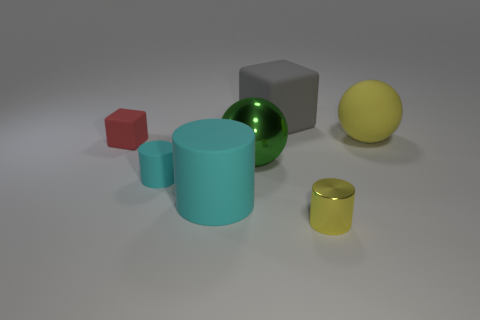Subtract all tiny rubber cylinders. How many cylinders are left? 2 Add 1 large green metal balls. How many objects exist? 8 Subtract all yellow cylinders. How many cylinders are left? 2 Subtract all cylinders. How many objects are left? 4 Subtract 3 cylinders. How many cylinders are left? 0 Subtract all blue balls. How many cyan cylinders are left? 2 Subtract all tiny yellow metal cylinders. Subtract all small rubber blocks. How many objects are left? 5 Add 5 red things. How many red things are left? 6 Add 2 tiny cyan things. How many tiny cyan things exist? 3 Subtract 0 brown balls. How many objects are left? 7 